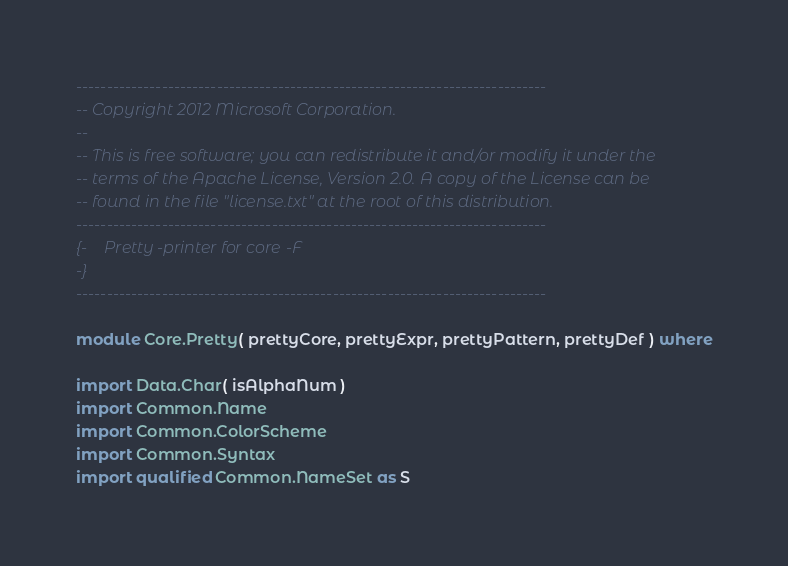Convert code to text. <code><loc_0><loc_0><loc_500><loc_500><_Haskell_>-----------------------------------------------------------------------------
-- Copyright 2012 Microsoft Corporation.
--
-- This is free software; you can redistribute it and/or modify it under the
-- terms of the Apache License, Version 2.0. A copy of the License can be
-- found in the file "license.txt" at the root of this distribution.
-----------------------------------------------------------------------------
{-    Pretty-printer for core-F
-}
-----------------------------------------------------------------------------

module Core.Pretty( prettyCore, prettyExpr, prettyPattern, prettyDef ) where

import Data.Char( isAlphaNum )
import Common.Name
import Common.ColorScheme
import Common.Syntax
import qualified Common.NameSet as S</code> 